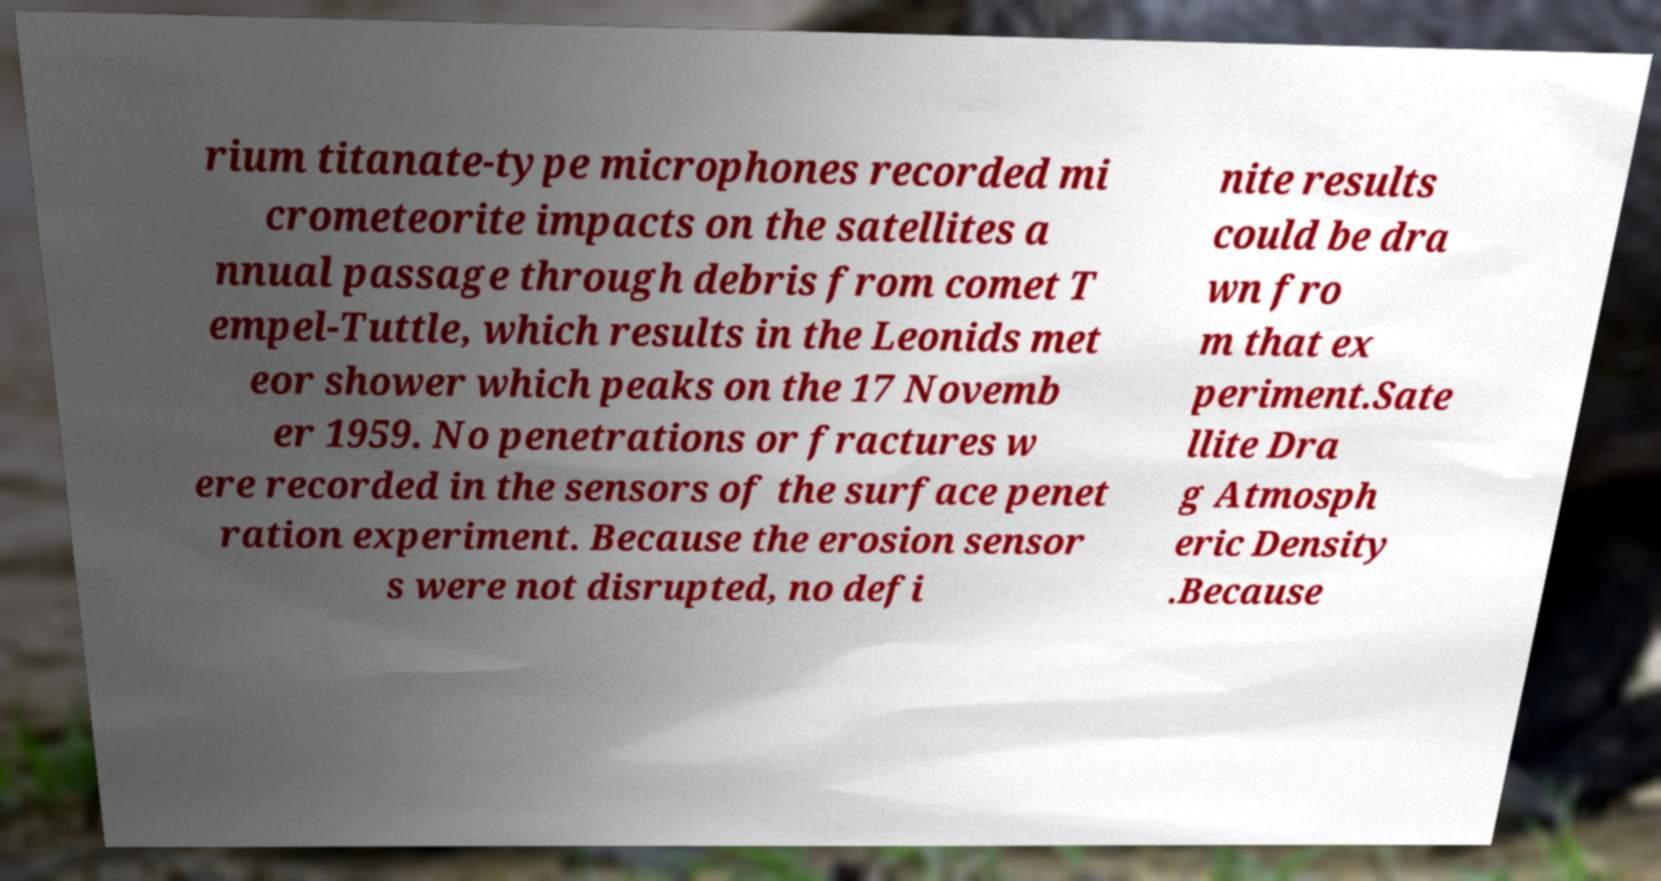What messages or text are displayed in this image? I need them in a readable, typed format. rium titanate-type microphones recorded mi crometeorite impacts on the satellites a nnual passage through debris from comet T empel-Tuttle, which results in the Leonids met eor shower which peaks on the 17 Novemb er 1959. No penetrations or fractures w ere recorded in the sensors of the surface penet ration experiment. Because the erosion sensor s were not disrupted, no defi nite results could be dra wn fro m that ex periment.Sate llite Dra g Atmosph eric Density .Because 